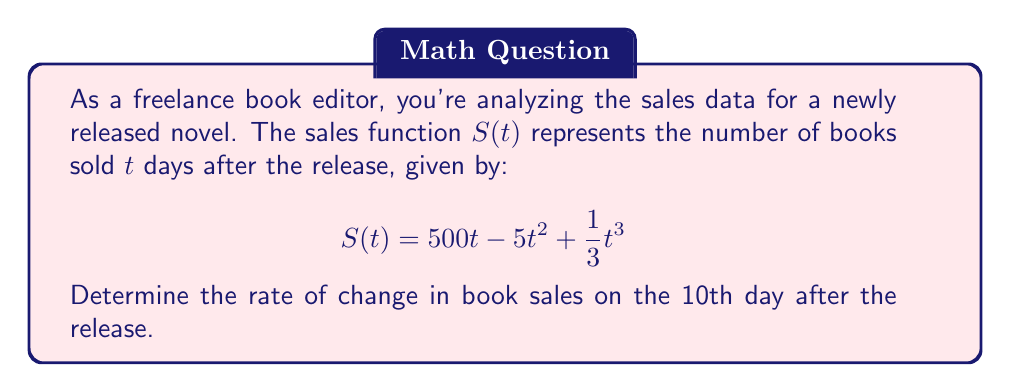Solve this math problem. To solve this problem, we need to follow these steps:

1) The rate of change in book sales is represented by the derivative of the sales function $S(t)$.

2) First, let's find the derivative of $S(t)$:

   $$\frac{d}{dt}S(t) = \frac{d}{dt}(500t - 5t^2 + \frac{1}{3}t^3)$$

   $$S'(t) = 500 - 10t + t^2$$

3) This derivative function $S'(t)$ gives us the rate of change in book sales at any time $t$.

4) To find the rate of change on the 10th day, we need to evaluate $S'(t)$ at $t = 10$:

   $$S'(10) = 500 - 10(10) + 10^2$$
   
   $$= 500 - 100 + 100$$
   
   $$= 500$$

5) Therefore, on the 10th day, the rate of change in book sales is 500 books per day.
Answer: The rate of change in book sales on the 10th day after the release is 500 books per day. 